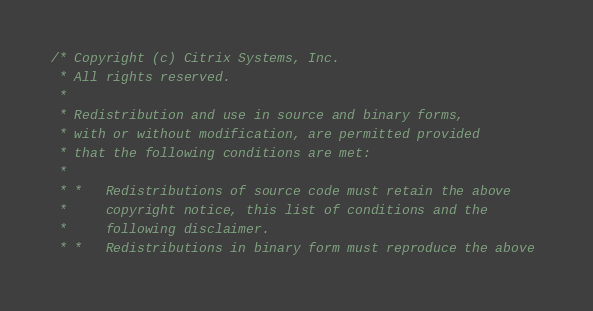<code> <loc_0><loc_0><loc_500><loc_500><_C++_>/* Copyright (c) Citrix Systems, Inc. 
 * All rights reserved. 
 * 
 * Redistribution and use in source and binary forms, 
 * with or without modification, are permitted provided 
 * that the following conditions are met: 
 * 
 * *   Redistributions of source code must retain the above 
 *     copyright notice, this list of conditions and the 
 *     following disclaimer. 
 * *   Redistributions in binary form must reproduce the above </code> 